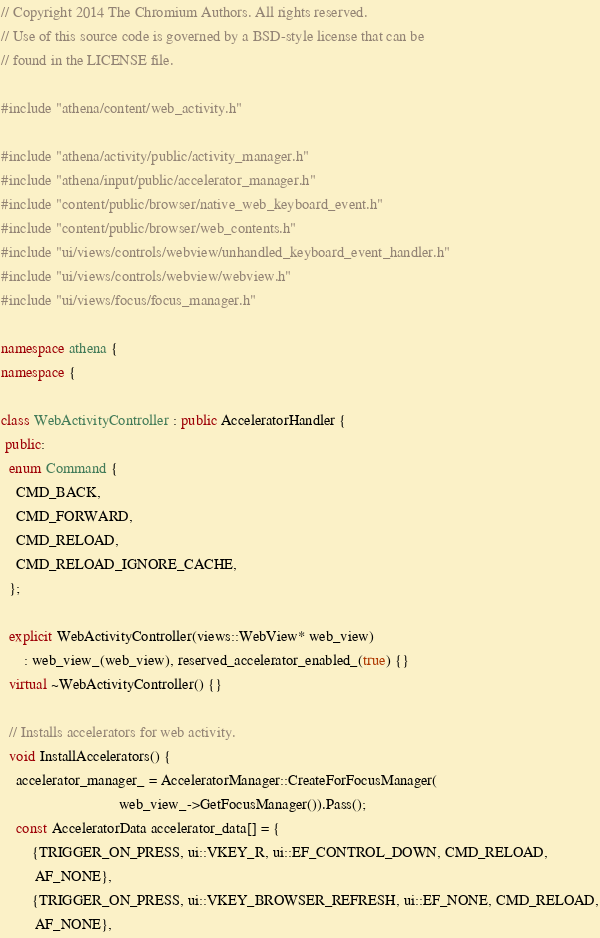Convert code to text. <code><loc_0><loc_0><loc_500><loc_500><_C++_>// Copyright 2014 The Chromium Authors. All rights reserved.
// Use of this source code is governed by a BSD-style license that can be
// found in the LICENSE file.

#include "athena/content/web_activity.h"

#include "athena/activity/public/activity_manager.h"
#include "athena/input/public/accelerator_manager.h"
#include "content/public/browser/native_web_keyboard_event.h"
#include "content/public/browser/web_contents.h"
#include "ui/views/controls/webview/unhandled_keyboard_event_handler.h"
#include "ui/views/controls/webview/webview.h"
#include "ui/views/focus/focus_manager.h"

namespace athena {
namespace {

class WebActivityController : public AcceleratorHandler {
 public:
  enum Command {
    CMD_BACK,
    CMD_FORWARD,
    CMD_RELOAD,
    CMD_RELOAD_IGNORE_CACHE,
  };

  explicit WebActivityController(views::WebView* web_view)
      : web_view_(web_view), reserved_accelerator_enabled_(true) {}
  virtual ~WebActivityController() {}

  // Installs accelerators for web activity.
  void InstallAccelerators() {
    accelerator_manager_ = AcceleratorManager::CreateForFocusManager(
                               web_view_->GetFocusManager()).Pass();
    const AcceleratorData accelerator_data[] = {
        {TRIGGER_ON_PRESS, ui::VKEY_R, ui::EF_CONTROL_DOWN, CMD_RELOAD,
         AF_NONE},
        {TRIGGER_ON_PRESS, ui::VKEY_BROWSER_REFRESH, ui::EF_NONE, CMD_RELOAD,
         AF_NONE},</code> 